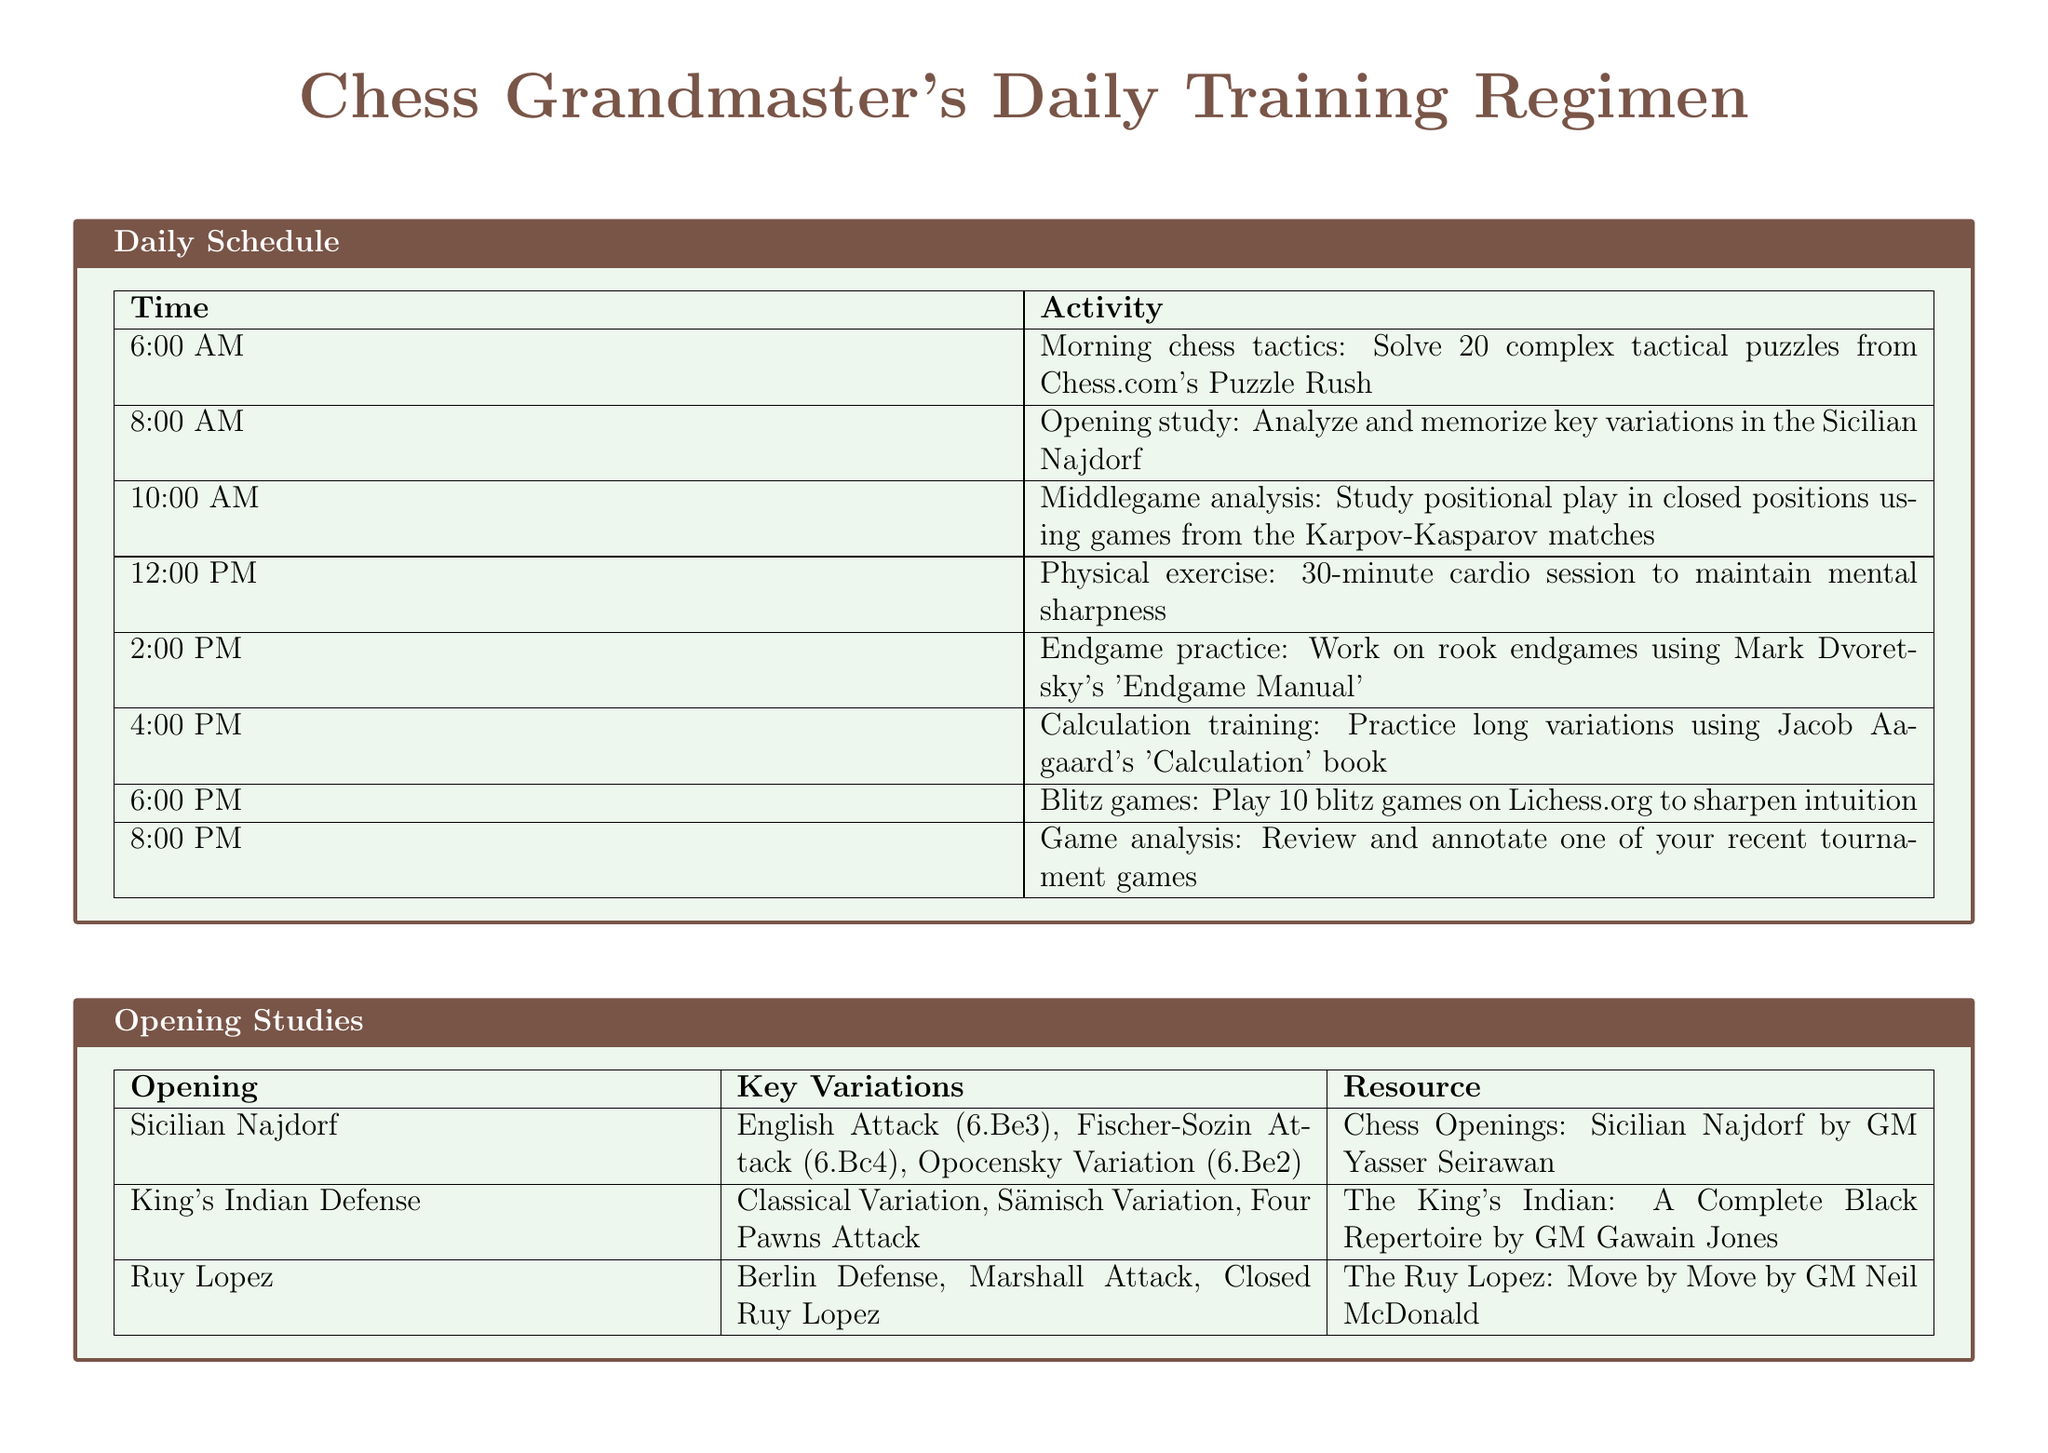what time is the endgame practice scheduled? The endgame practice is scheduled at 2:00 PM.
Answer: 2:00 PM how many tactical puzzles are solved in the morning session? The morning chess tactics involve solving 20 complex tactical puzzles.
Answer: 20 which opening is studied at 8:00 AM? The opening studied at 8:00 AM is the Sicilian Najdorf.
Answer: Sicilian Najdorf what is the resource for rook endgames? The resource for rook endgames is "100 Endgames You Must Know by GM Jesus de la Villa."
Answer: 100 Endgames You Must Know by GM Jesus de la Villa how long is the cardio session scheduled for? The cardio session is scheduled for 30 minutes.
Answer: 30 minutes which chess software is used for game analysis? The chess software used for game analysis is ChessBase 16.
Answer: ChessBase 16 what type of exercises are practiced using Jacob Aagaard's book? The exercises practiced using Jacob Aagaard's book involve long variations.
Answer: Long variations how many blitz games are played in the evening? In the evening, 10 blitz games are played.
Answer: 10 what is the key variation for the King's Indian Defense? One of the key variations for the King's Indian Defense is the Classical Variation.
Answer: Classical Variation 